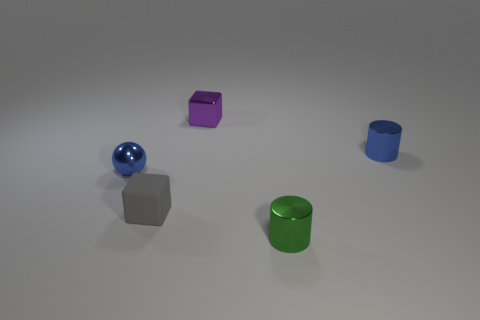Add 3 rubber blocks. How many objects exist? 8 Subtract all cylinders. How many objects are left? 3 Add 4 blue spheres. How many blue spheres exist? 5 Subtract 1 purple cubes. How many objects are left? 4 Subtract all small cyan metal cubes. Subtract all tiny metallic cylinders. How many objects are left? 3 Add 2 small blue things. How many small blue things are left? 4 